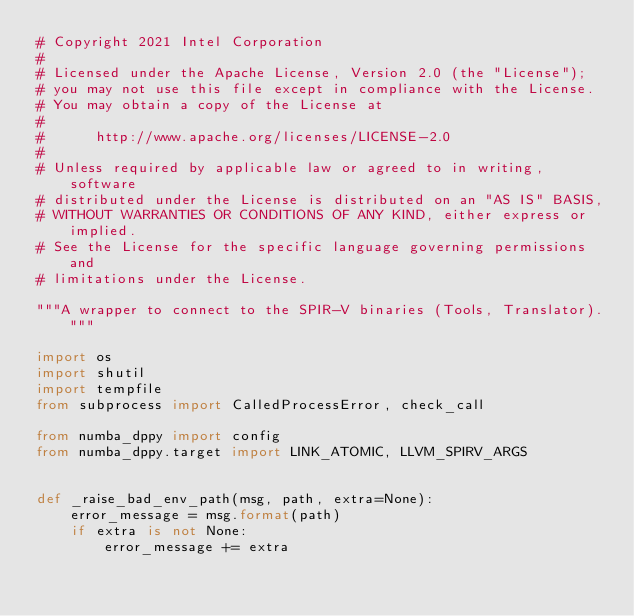Convert code to text. <code><loc_0><loc_0><loc_500><loc_500><_Python_># Copyright 2021 Intel Corporation
#
# Licensed under the Apache License, Version 2.0 (the "License");
# you may not use this file except in compliance with the License.
# You may obtain a copy of the License at
#
#      http://www.apache.org/licenses/LICENSE-2.0
#
# Unless required by applicable law or agreed to in writing, software
# distributed under the License is distributed on an "AS IS" BASIS,
# WITHOUT WARRANTIES OR CONDITIONS OF ANY KIND, either express or implied.
# See the License for the specific language governing permissions and
# limitations under the License.

"""A wrapper to connect to the SPIR-V binaries (Tools, Translator)."""

import os
import shutil
import tempfile
from subprocess import CalledProcessError, check_call

from numba_dppy import config
from numba_dppy.target import LINK_ATOMIC, LLVM_SPIRV_ARGS


def _raise_bad_env_path(msg, path, extra=None):
    error_message = msg.format(path)
    if extra is not None:
        error_message += extra</code> 